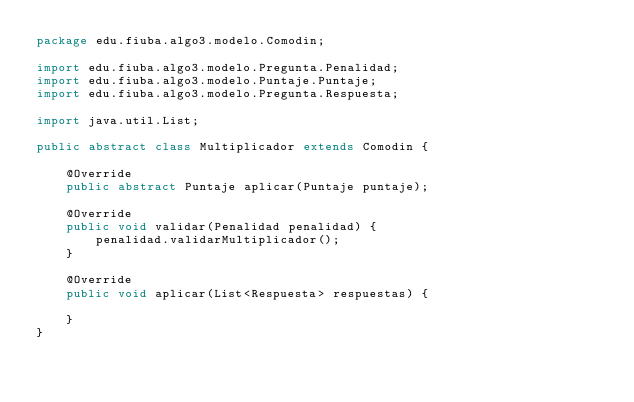Convert code to text. <code><loc_0><loc_0><loc_500><loc_500><_Java_>package edu.fiuba.algo3.modelo.Comodin;

import edu.fiuba.algo3.modelo.Pregunta.Penalidad;
import edu.fiuba.algo3.modelo.Puntaje.Puntaje;
import edu.fiuba.algo3.modelo.Pregunta.Respuesta;

import java.util.List;

public abstract class Multiplicador extends Comodin {

    @Override
    public abstract Puntaje aplicar(Puntaje puntaje);

    @Override
    public void validar(Penalidad penalidad) {
        penalidad.validarMultiplicador();
    }

    @Override
    public void aplicar(List<Respuesta> respuestas) {

    }
}
</code> 